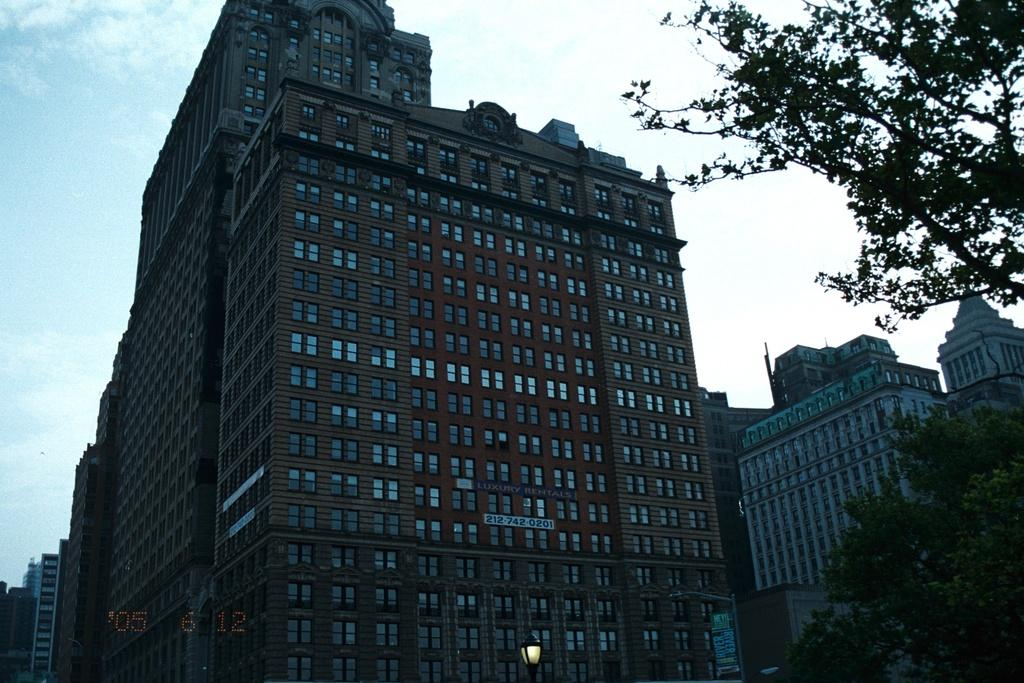What structures can be seen in the picture? There are buildings in the picture. What type of vegetation is on the right side of the picture? There are trees on the right side of the picture. What is visible at the top of the picture? The sky is visible at the top of the picture. What is the condition of the sky in the picture? The sky is clear in the picture. Can you see a snail climbing up one of the buildings in the picture? There is no snail present in the image; it only features buildings, trees, and a clear sky. Is there a unit of measurement visible in the picture? There is no unit of measurement present in the image. 